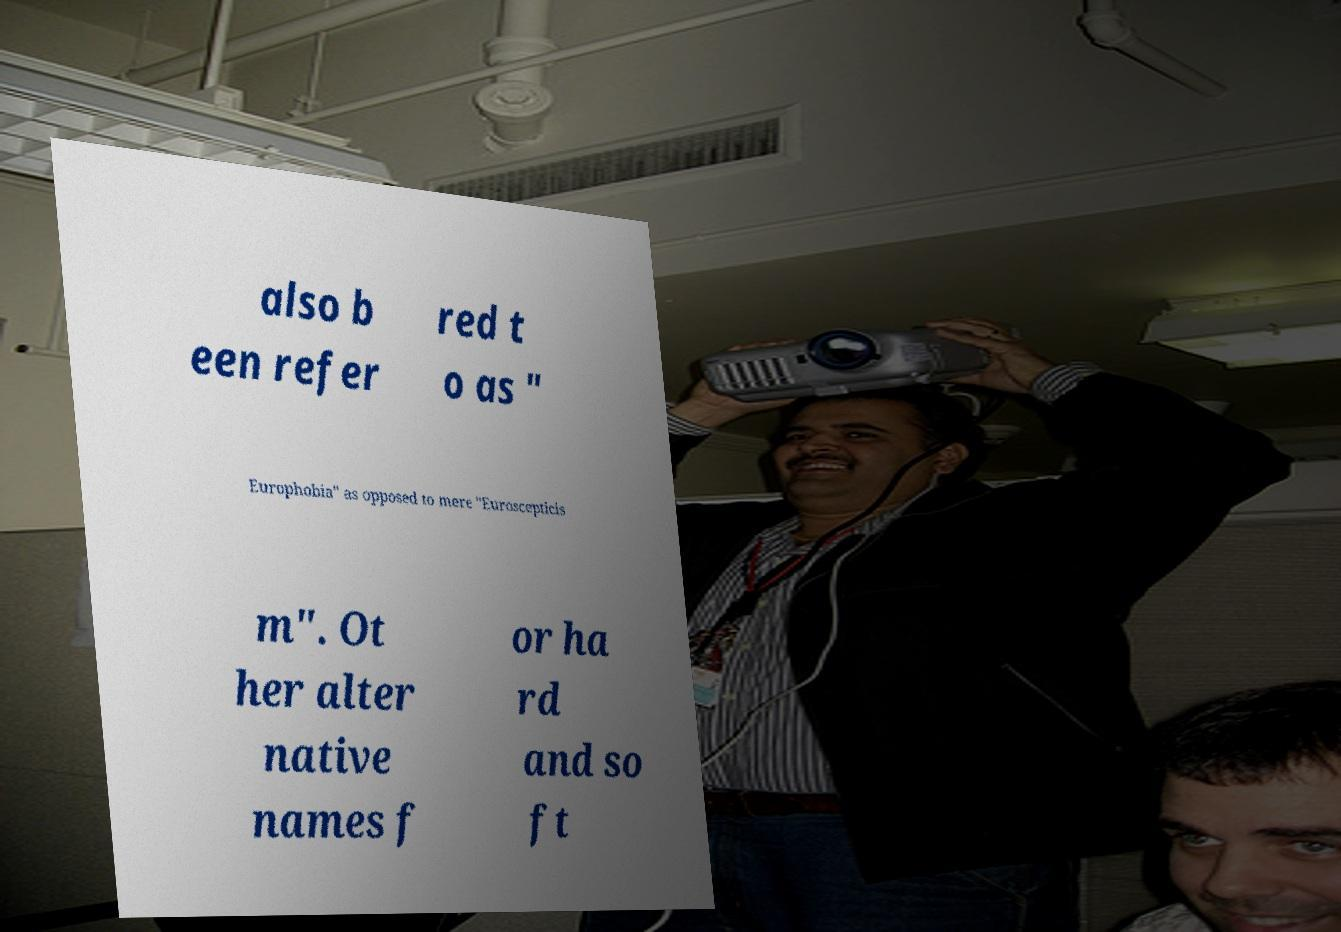Can you read and provide the text displayed in the image?This photo seems to have some interesting text. Can you extract and type it out for me? also b een refer red t o as " Europhobia" as opposed to mere "Euroscepticis m". Ot her alter native names f or ha rd and so ft 